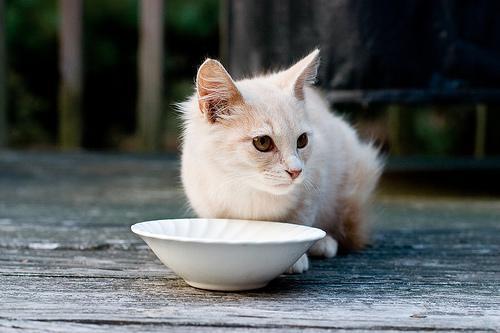How many cats in the picture?
Give a very brief answer. 1. How many bowls?
Give a very brief answer. 1. 